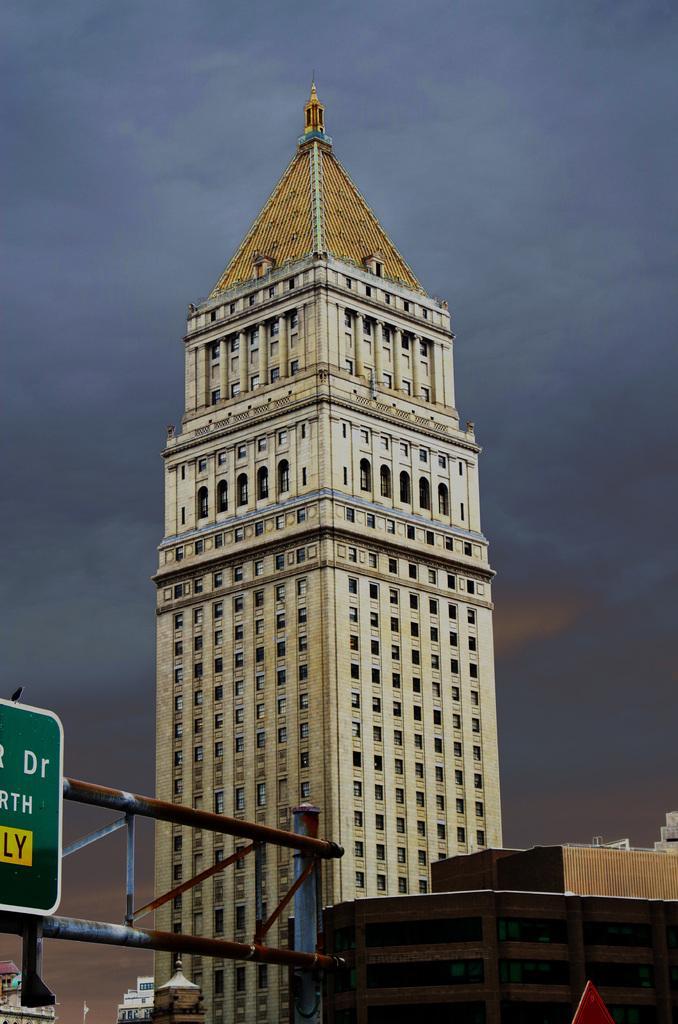Please provide a concise description of this image. In this image I can see few metal poles, the green colored board to the poles and few buildings. In the background I can see the sky. 